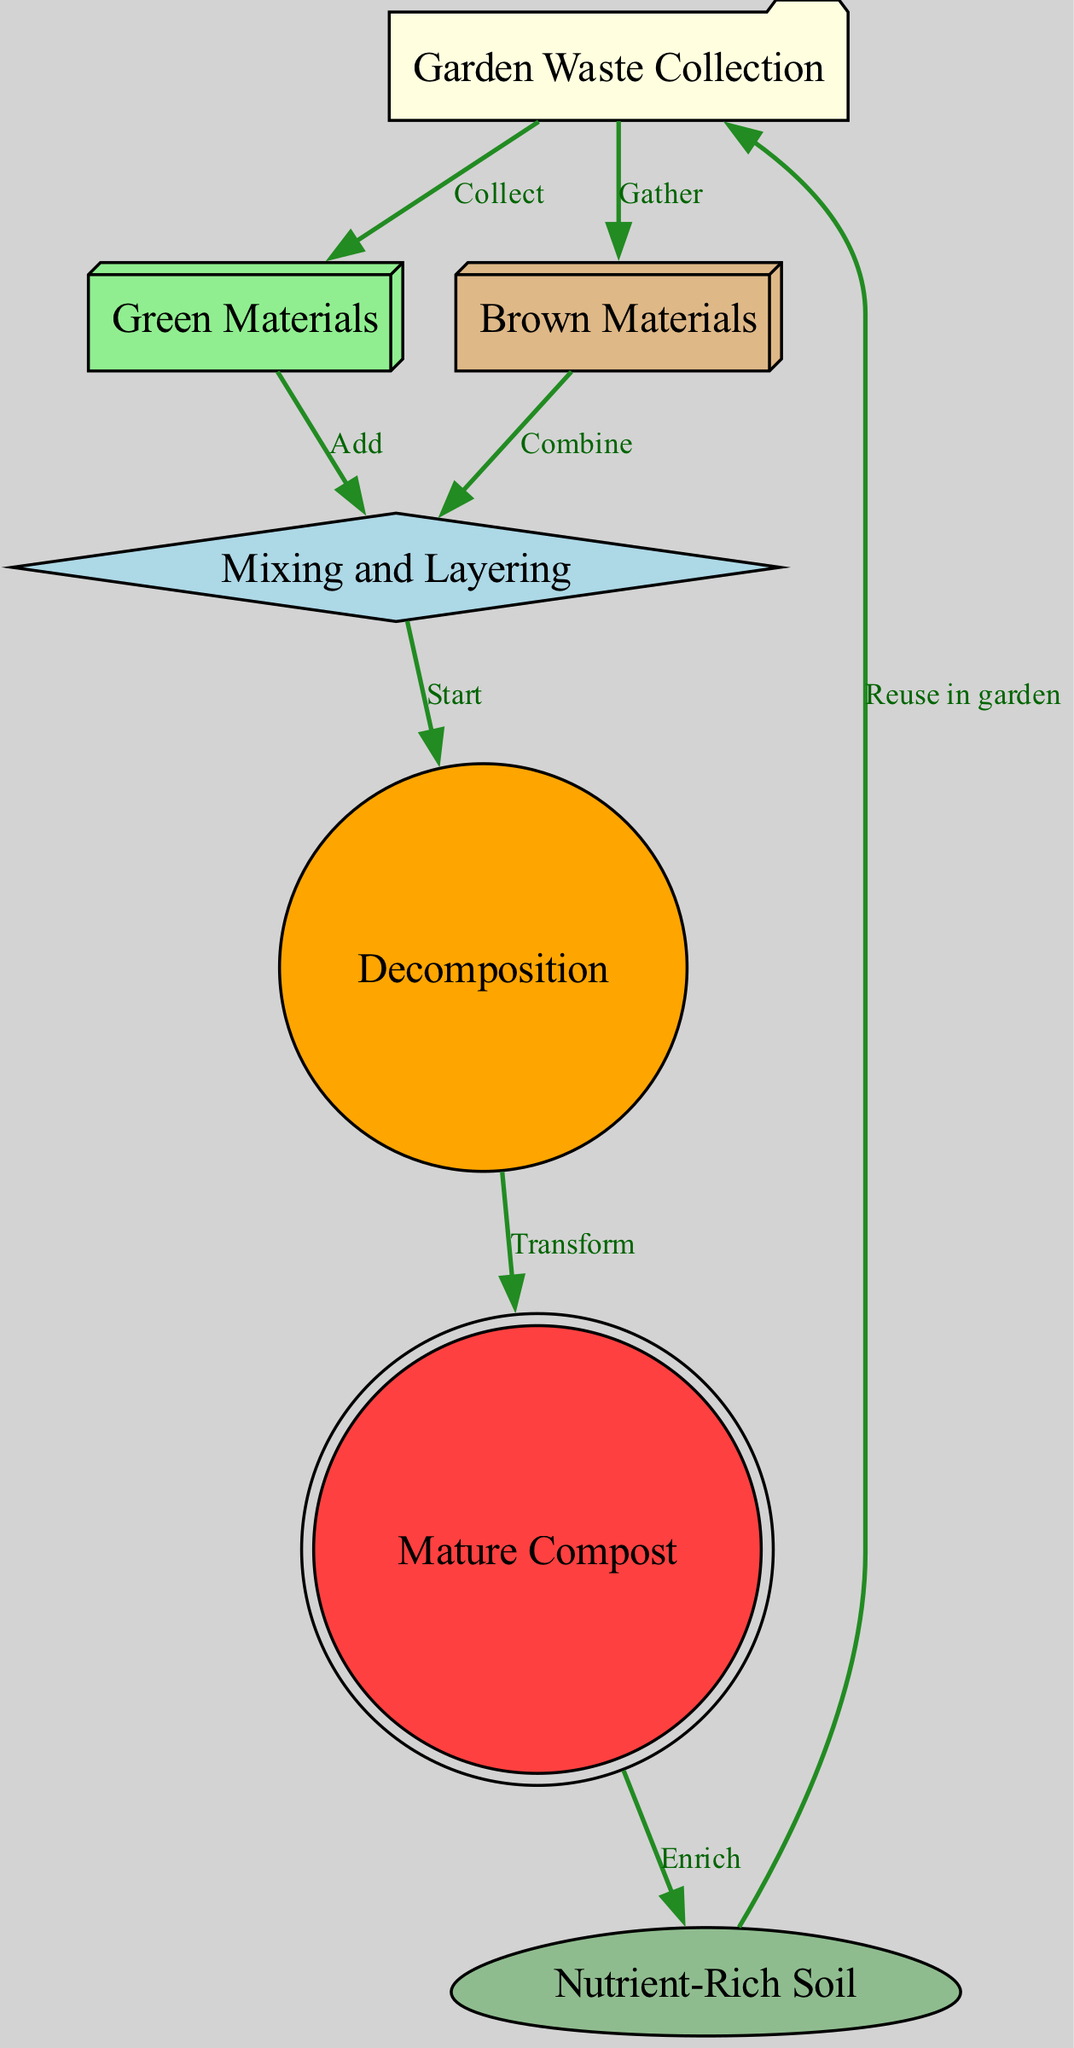What is the first step in the composting process? The first step is "Garden Waste Collection," as indicated by the starting node in the diagram.
Answer: Garden Waste Collection How many nodes are there in the diagram? By counting the unique stages listed in the diagram, there are seven distinct nodes representing steps in the composting process.
Answer: Seven Which materials are combined during the mixing and layering stage? The "Mixing and Layering" stage involves both "Green Materials" and "Brown Materials," as shown by the edges coming from those nodes.
Answer: Green Materials and Brown Materials What happens to the mature compost? The mature compost is turned into "Nutrient-Rich Soil," as indicated by the directed edge from the "Mature Compost" node to the "Nutrient-Rich Soil" node.
Answer: Nutrient-Rich Soil How does the composting process begin? The composting process begins by "Collecting" garden waste, as shown in the first edge from the "Garden Waste Collection" node to the "Green Materials" node.
Answer: Collecting What is the relationship between decomposition and mature compost? The relationship is that decomposition "Transforms" into mature compost, as indicated by the directed edge leading from the "Decomposition" node to the "Mature Compost" node, showing a cause-effect relationship in the process.
Answer: Transforms Which stage follows "Mixing and Layering"? The stage that follows "Mixing and Layering" is "Decomposition," as indicated by the directed edge leading from the "Mixing and Layering" node to the "Decomposition" node.
Answer: Decomposition What do you do with nutrient-rich soil? The nutrient-rich soil is "Reused in garden," as indicated by the directed edge leading back to the "Garden Waste Collection" node, indicating a cyclical nature of the composting process.
Answer: Reused in garden What two types of materials are necessary for mixing? The necessary materials for mixing are "Green Materials" and "Brown Materials", as shown in the edges leading into the "Mixing and Layering" node.
Answer: Green Materials and Brown Materials 